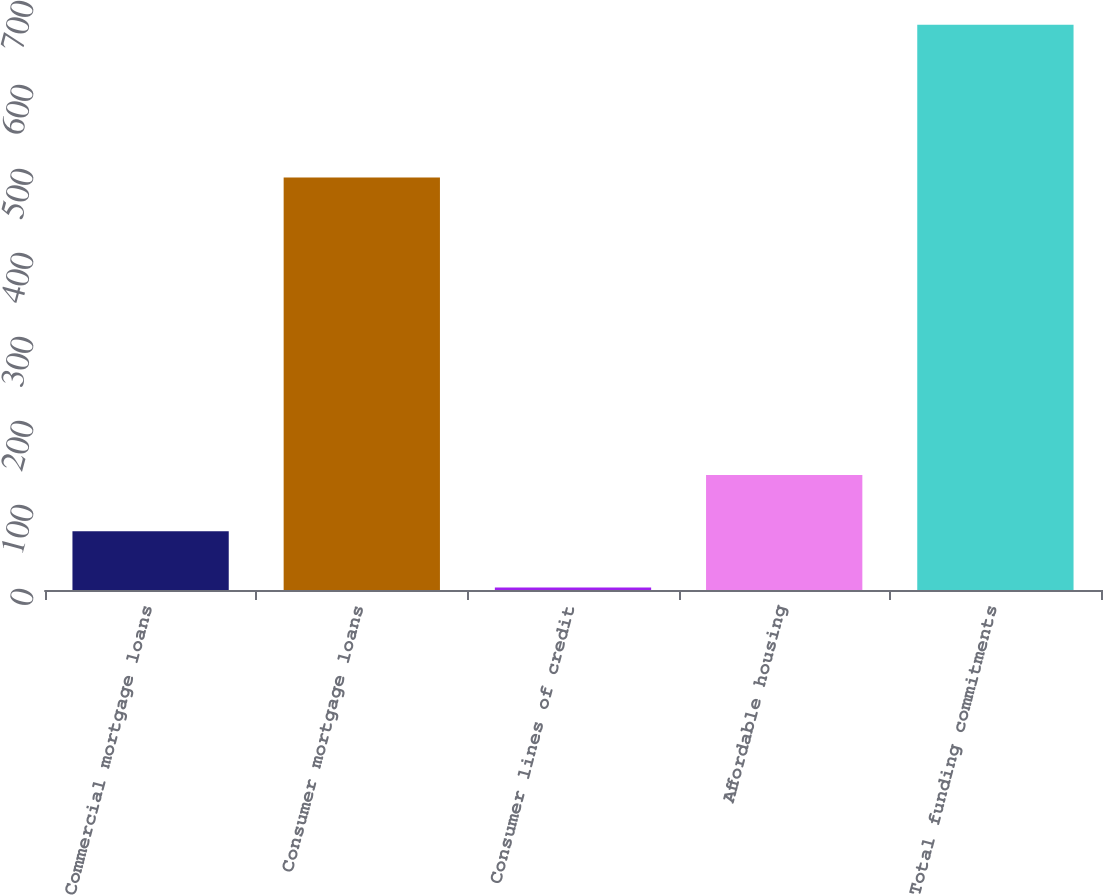<chart> <loc_0><loc_0><loc_500><loc_500><bar_chart><fcel>Commercial mortgage loans<fcel>Consumer mortgage loans<fcel>Consumer lines of credit<fcel>Affordable housing<fcel>Total funding commitments<nl><fcel>70<fcel>491<fcel>3<fcel>137<fcel>673<nl></chart> 